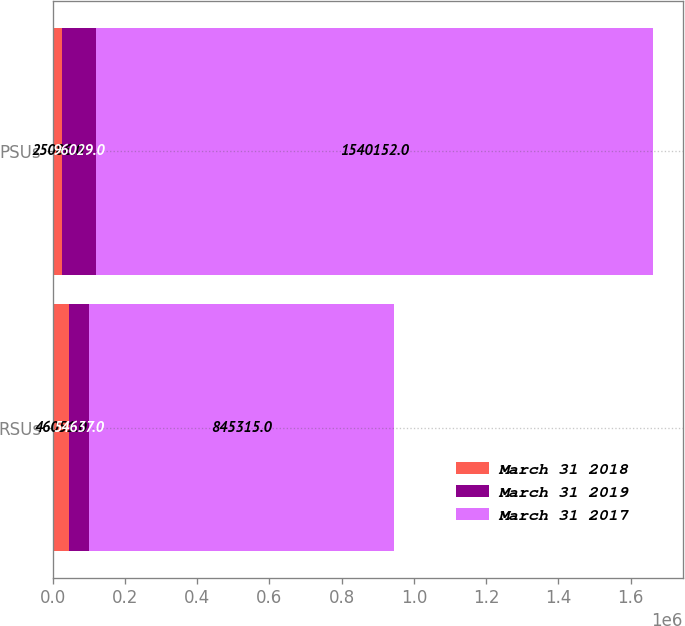<chart> <loc_0><loc_0><loc_500><loc_500><stacked_bar_chart><ecel><fcel>RSUs<fcel>PSUs<nl><fcel>March 31 2018<fcel>46051<fcel>25086<nl><fcel>March 31 2019<fcel>54637<fcel>96029<nl><fcel>March 31 2017<fcel>845315<fcel>1.54015e+06<nl></chart> 